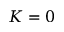<formula> <loc_0><loc_0><loc_500><loc_500>K = 0</formula> 